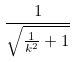<formula> <loc_0><loc_0><loc_500><loc_500>\frac { 1 } { \sqrt { \frac { 1 } { k ^ { 2 } } + 1 } }</formula> 